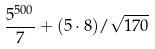<formula> <loc_0><loc_0><loc_500><loc_500>\frac { 5 ^ { 5 0 0 } } { 7 } + ( 5 \cdot 8 ) / \sqrt { 1 7 0 }</formula> 